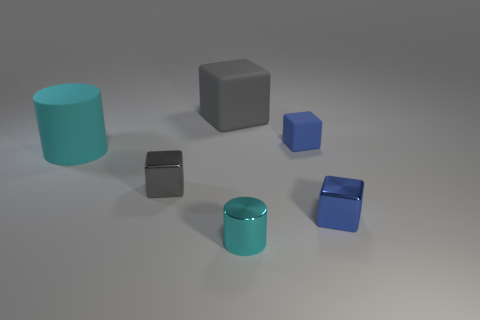Can you describe the texture of the surface on which the objects are placed? The surface appears to be smooth with a matte finish, and it reflects a subtle amount of light, indicating it might have a slightly reflective quality. 